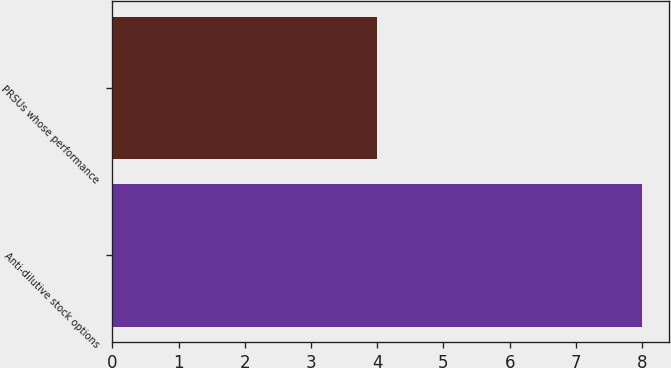Convert chart. <chart><loc_0><loc_0><loc_500><loc_500><bar_chart><fcel>Anti-dilutive stock options<fcel>PRSUs whose performance<nl><fcel>8<fcel>4<nl></chart> 